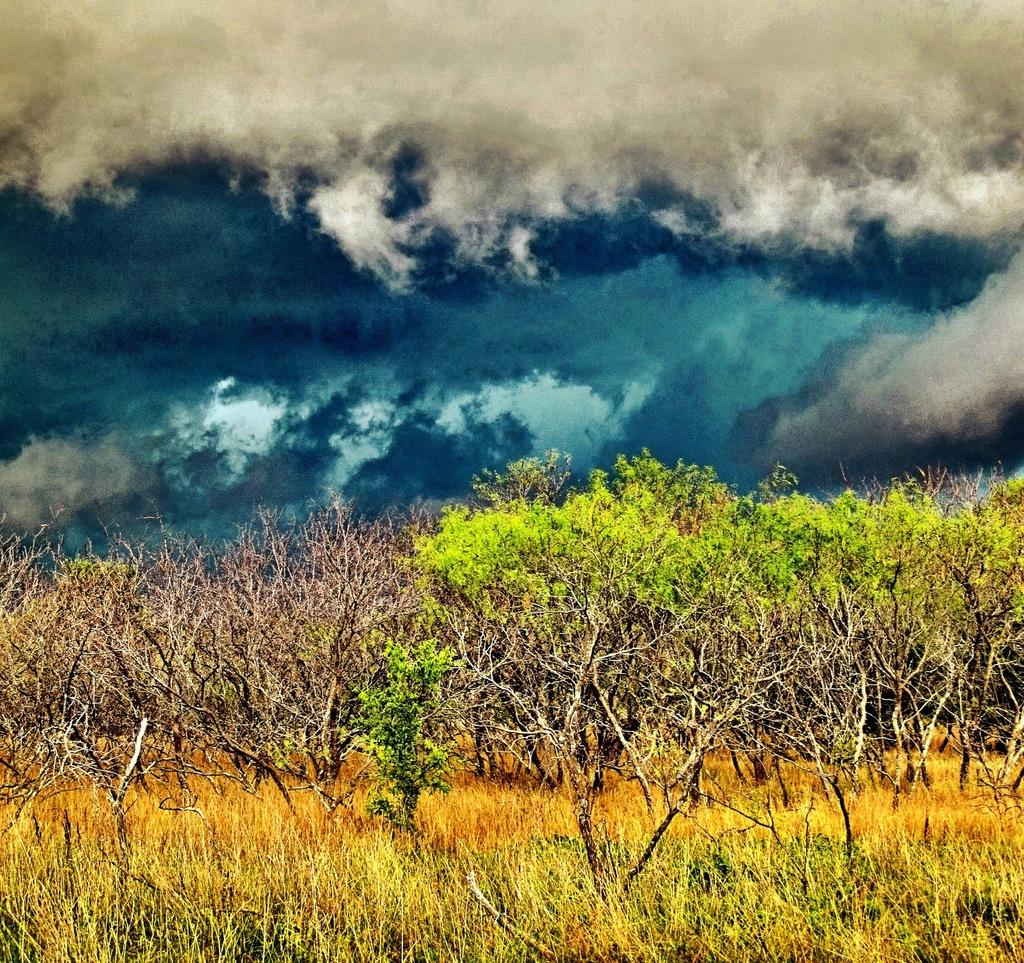What type of vegetation is present in the image? There is grass in the image. What other natural elements can be seen in the image? There are trees in the image. What is visible in the sky at the top of the image? There are clouds visible in the sky at the top of the image. How many men are balancing on the clouds in the image? There are no men present in the image, and therefore no one is balancing on the clouds. 